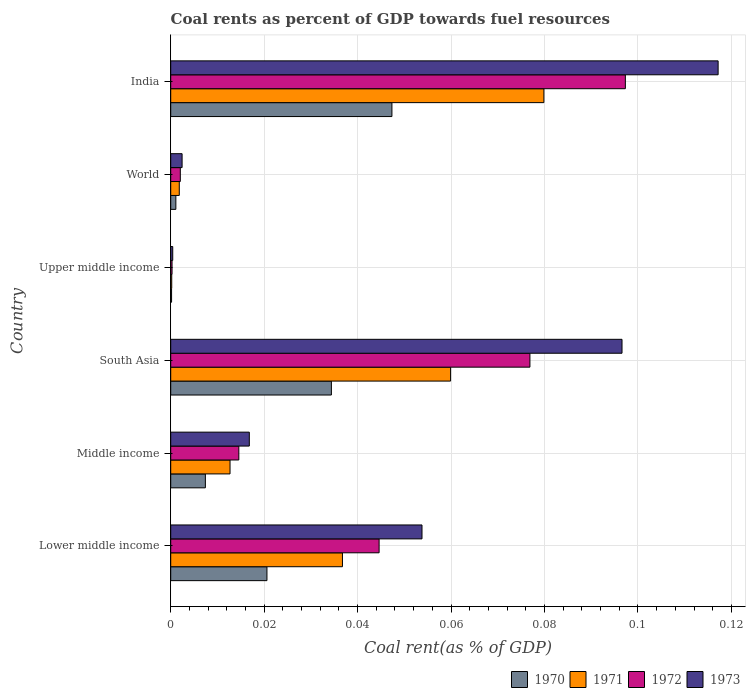How many groups of bars are there?
Offer a very short reply. 6. Are the number of bars per tick equal to the number of legend labels?
Keep it short and to the point. Yes. How many bars are there on the 3rd tick from the bottom?
Keep it short and to the point. 4. What is the label of the 4th group of bars from the top?
Your response must be concise. South Asia. In how many cases, is the number of bars for a given country not equal to the number of legend labels?
Your answer should be compact. 0. What is the coal rent in 1971 in World?
Your response must be concise. 0. Across all countries, what is the maximum coal rent in 1971?
Make the answer very short. 0.08. Across all countries, what is the minimum coal rent in 1972?
Keep it short and to the point. 0. In which country was the coal rent in 1970 minimum?
Give a very brief answer. Upper middle income. What is the total coal rent in 1970 in the graph?
Provide a succinct answer. 0.11. What is the difference between the coal rent in 1971 in Lower middle income and that in Upper middle income?
Your response must be concise. 0.04. What is the difference between the coal rent in 1971 in South Asia and the coal rent in 1972 in Middle income?
Give a very brief answer. 0.05. What is the average coal rent in 1972 per country?
Offer a terse response. 0.04. What is the difference between the coal rent in 1971 and coal rent in 1972 in South Asia?
Provide a short and direct response. -0.02. What is the ratio of the coal rent in 1970 in India to that in Upper middle income?
Offer a very short reply. 257.52. What is the difference between the highest and the second highest coal rent in 1972?
Make the answer very short. 0.02. What is the difference between the highest and the lowest coal rent in 1971?
Ensure brevity in your answer.  0.08. Is the sum of the coal rent in 1971 in Lower middle income and World greater than the maximum coal rent in 1972 across all countries?
Give a very brief answer. No. Is it the case that in every country, the sum of the coal rent in 1973 and coal rent in 1971 is greater than the sum of coal rent in 1970 and coal rent in 1972?
Give a very brief answer. No. Is it the case that in every country, the sum of the coal rent in 1973 and coal rent in 1972 is greater than the coal rent in 1970?
Provide a succinct answer. Yes. How many bars are there?
Your answer should be very brief. 24. How many countries are there in the graph?
Your answer should be compact. 6. What is the difference between two consecutive major ticks on the X-axis?
Provide a short and direct response. 0.02. How are the legend labels stacked?
Your answer should be very brief. Horizontal. What is the title of the graph?
Offer a terse response. Coal rents as percent of GDP towards fuel resources. What is the label or title of the X-axis?
Ensure brevity in your answer.  Coal rent(as % of GDP). What is the label or title of the Y-axis?
Give a very brief answer. Country. What is the Coal rent(as % of GDP) in 1970 in Lower middle income?
Offer a very short reply. 0.02. What is the Coal rent(as % of GDP) of 1971 in Lower middle income?
Your answer should be compact. 0.04. What is the Coal rent(as % of GDP) in 1972 in Lower middle income?
Ensure brevity in your answer.  0.04. What is the Coal rent(as % of GDP) in 1973 in Lower middle income?
Give a very brief answer. 0.05. What is the Coal rent(as % of GDP) in 1970 in Middle income?
Provide a short and direct response. 0.01. What is the Coal rent(as % of GDP) of 1971 in Middle income?
Make the answer very short. 0.01. What is the Coal rent(as % of GDP) in 1972 in Middle income?
Your answer should be compact. 0.01. What is the Coal rent(as % of GDP) in 1973 in Middle income?
Give a very brief answer. 0.02. What is the Coal rent(as % of GDP) of 1970 in South Asia?
Offer a very short reply. 0.03. What is the Coal rent(as % of GDP) of 1971 in South Asia?
Keep it short and to the point. 0.06. What is the Coal rent(as % of GDP) in 1972 in South Asia?
Ensure brevity in your answer.  0.08. What is the Coal rent(as % of GDP) in 1973 in South Asia?
Give a very brief answer. 0.1. What is the Coal rent(as % of GDP) in 1970 in Upper middle income?
Provide a succinct answer. 0. What is the Coal rent(as % of GDP) in 1971 in Upper middle income?
Keep it short and to the point. 0. What is the Coal rent(as % of GDP) of 1972 in Upper middle income?
Your response must be concise. 0. What is the Coal rent(as % of GDP) in 1973 in Upper middle income?
Your answer should be very brief. 0. What is the Coal rent(as % of GDP) in 1970 in World?
Give a very brief answer. 0. What is the Coal rent(as % of GDP) in 1971 in World?
Your answer should be very brief. 0. What is the Coal rent(as % of GDP) of 1972 in World?
Ensure brevity in your answer.  0. What is the Coal rent(as % of GDP) of 1973 in World?
Give a very brief answer. 0. What is the Coal rent(as % of GDP) in 1970 in India?
Your response must be concise. 0.05. What is the Coal rent(as % of GDP) in 1971 in India?
Offer a terse response. 0.08. What is the Coal rent(as % of GDP) in 1972 in India?
Make the answer very short. 0.1. What is the Coal rent(as % of GDP) of 1973 in India?
Provide a succinct answer. 0.12. Across all countries, what is the maximum Coal rent(as % of GDP) of 1970?
Keep it short and to the point. 0.05. Across all countries, what is the maximum Coal rent(as % of GDP) in 1971?
Make the answer very short. 0.08. Across all countries, what is the maximum Coal rent(as % of GDP) in 1972?
Keep it short and to the point. 0.1. Across all countries, what is the maximum Coal rent(as % of GDP) in 1973?
Provide a short and direct response. 0.12. Across all countries, what is the minimum Coal rent(as % of GDP) in 1970?
Your answer should be compact. 0. Across all countries, what is the minimum Coal rent(as % of GDP) in 1971?
Ensure brevity in your answer.  0. Across all countries, what is the minimum Coal rent(as % of GDP) of 1972?
Offer a terse response. 0. Across all countries, what is the minimum Coal rent(as % of GDP) of 1973?
Offer a terse response. 0. What is the total Coal rent(as % of GDP) in 1970 in the graph?
Your answer should be compact. 0.11. What is the total Coal rent(as % of GDP) in 1971 in the graph?
Provide a short and direct response. 0.19. What is the total Coal rent(as % of GDP) in 1972 in the graph?
Provide a short and direct response. 0.24. What is the total Coal rent(as % of GDP) of 1973 in the graph?
Offer a very short reply. 0.29. What is the difference between the Coal rent(as % of GDP) of 1970 in Lower middle income and that in Middle income?
Your answer should be compact. 0.01. What is the difference between the Coal rent(as % of GDP) in 1971 in Lower middle income and that in Middle income?
Your response must be concise. 0.02. What is the difference between the Coal rent(as % of GDP) of 1972 in Lower middle income and that in Middle income?
Your answer should be compact. 0.03. What is the difference between the Coal rent(as % of GDP) in 1973 in Lower middle income and that in Middle income?
Your answer should be very brief. 0.04. What is the difference between the Coal rent(as % of GDP) in 1970 in Lower middle income and that in South Asia?
Offer a very short reply. -0.01. What is the difference between the Coal rent(as % of GDP) in 1971 in Lower middle income and that in South Asia?
Your answer should be very brief. -0.02. What is the difference between the Coal rent(as % of GDP) in 1972 in Lower middle income and that in South Asia?
Your answer should be compact. -0.03. What is the difference between the Coal rent(as % of GDP) of 1973 in Lower middle income and that in South Asia?
Offer a very short reply. -0.04. What is the difference between the Coal rent(as % of GDP) of 1970 in Lower middle income and that in Upper middle income?
Your answer should be compact. 0.02. What is the difference between the Coal rent(as % of GDP) of 1971 in Lower middle income and that in Upper middle income?
Your answer should be very brief. 0.04. What is the difference between the Coal rent(as % of GDP) of 1972 in Lower middle income and that in Upper middle income?
Your response must be concise. 0.04. What is the difference between the Coal rent(as % of GDP) of 1973 in Lower middle income and that in Upper middle income?
Keep it short and to the point. 0.05. What is the difference between the Coal rent(as % of GDP) in 1970 in Lower middle income and that in World?
Your answer should be compact. 0.02. What is the difference between the Coal rent(as % of GDP) in 1971 in Lower middle income and that in World?
Provide a succinct answer. 0.03. What is the difference between the Coal rent(as % of GDP) in 1972 in Lower middle income and that in World?
Your answer should be compact. 0.04. What is the difference between the Coal rent(as % of GDP) of 1973 in Lower middle income and that in World?
Your answer should be compact. 0.05. What is the difference between the Coal rent(as % of GDP) of 1970 in Lower middle income and that in India?
Ensure brevity in your answer.  -0.03. What is the difference between the Coal rent(as % of GDP) of 1971 in Lower middle income and that in India?
Your answer should be very brief. -0.04. What is the difference between the Coal rent(as % of GDP) in 1972 in Lower middle income and that in India?
Provide a short and direct response. -0.05. What is the difference between the Coal rent(as % of GDP) in 1973 in Lower middle income and that in India?
Ensure brevity in your answer.  -0.06. What is the difference between the Coal rent(as % of GDP) in 1970 in Middle income and that in South Asia?
Your answer should be compact. -0.03. What is the difference between the Coal rent(as % of GDP) in 1971 in Middle income and that in South Asia?
Your answer should be compact. -0.05. What is the difference between the Coal rent(as % of GDP) in 1972 in Middle income and that in South Asia?
Provide a short and direct response. -0.06. What is the difference between the Coal rent(as % of GDP) of 1973 in Middle income and that in South Asia?
Make the answer very short. -0.08. What is the difference between the Coal rent(as % of GDP) in 1970 in Middle income and that in Upper middle income?
Offer a terse response. 0.01. What is the difference between the Coal rent(as % of GDP) of 1971 in Middle income and that in Upper middle income?
Keep it short and to the point. 0.01. What is the difference between the Coal rent(as % of GDP) in 1972 in Middle income and that in Upper middle income?
Keep it short and to the point. 0.01. What is the difference between the Coal rent(as % of GDP) in 1973 in Middle income and that in Upper middle income?
Make the answer very short. 0.02. What is the difference between the Coal rent(as % of GDP) of 1970 in Middle income and that in World?
Provide a short and direct response. 0.01. What is the difference between the Coal rent(as % of GDP) in 1971 in Middle income and that in World?
Provide a short and direct response. 0.01. What is the difference between the Coal rent(as % of GDP) of 1972 in Middle income and that in World?
Make the answer very short. 0.01. What is the difference between the Coal rent(as % of GDP) in 1973 in Middle income and that in World?
Provide a short and direct response. 0.01. What is the difference between the Coal rent(as % of GDP) of 1970 in Middle income and that in India?
Give a very brief answer. -0.04. What is the difference between the Coal rent(as % of GDP) in 1971 in Middle income and that in India?
Your response must be concise. -0.07. What is the difference between the Coal rent(as % of GDP) of 1972 in Middle income and that in India?
Your response must be concise. -0.08. What is the difference between the Coal rent(as % of GDP) of 1973 in Middle income and that in India?
Your answer should be very brief. -0.1. What is the difference between the Coal rent(as % of GDP) of 1970 in South Asia and that in Upper middle income?
Give a very brief answer. 0.03. What is the difference between the Coal rent(as % of GDP) of 1971 in South Asia and that in Upper middle income?
Your response must be concise. 0.06. What is the difference between the Coal rent(as % of GDP) of 1972 in South Asia and that in Upper middle income?
Ensure brevity in your answer.  0.08. What is the difference between the Coal rent(as % of GDP) of 1973 in South Asia and that in Upper middle income?
Your answer should be compact. 0.1. What is the difference between the Coal rent(as % of GDP) in 1970 in South Asia and that in World?
Ensure brevity in your answer.  0.03. What is the difference between the Coal rent(as % of GDP) of 1971 in South Asia and that in World?
Provide a short and direct response. 0.06. What is the difference between the Coal rent(as % of GDP) of 1972 in South Asia and that in World?
Make the answer very short. 0.07. What is the difference between the Coal rent(as % of GDP) in 1973 in South Asia and that in World?
Your answer should be very brief. 0.09. What is the difference between the Coal rent(as % of GDP) of 1970 in South Asia and that in India?
Offer a terse response. -0.01. What is the difference between the Coal rent(as % of GDP) of 1971 in South Asia and that in India?
Provide a short and direct response. -0.02. What is the difference between the Coal rent(as % of GDP) in 1972 in South Asia and that in India?
Give a very brief answer. -0.02. What is the difference between the Coal rent(as % of GDP) in 1973 in South Asia and that in India?
Provide a short and direct response. -0.02. What is the difference between the Coal rent(as % of GDP) in 1970 in Upper middle income and that in World?
Make the answer very short. -0. What is the difference between the Coal rent(as % of GDP) of 1971 in Upper middle income and that in World?
Keep it short and to the point. -0. What is the difference between the Coal rent(as % of GDP) in 1972 in Upper middle income and that in World?
Keep it short and to the point. -0. What is the difference between the Coal rent(as % of GDP) in 1973 in Upper middle income and that in World?
Provide a short and direct response. -0. What is the difference between the Coal rent(as % of GDP) in 1970 in Upper middle income and that in India?
Give a very brief answer. -0.05. What is the difference between the Coal rent(as % of GDP) of 1971 in Upper middle income and that in India?
Provide a succinct answer. -0.08. What is the difference between the Coal rent(as % of GDP) of 1972 in Upper middle income and that in India?
Your response must be concise. -0.1. What is the difference between the Coal rent(as % of GDP) of 1973 in Upper middle income and that in India?
Provide a short and direct response. -0.12. What is the difference between the Coal rent(as % of GDP) in 1970 in World and that in India?
Your answer should be compact. -0.05. What is the difference between the Coal rent(as % of GDP) of 1971 in World and that in India?
Provide a succinct answer. -0.08. What is the difference between the Coal rent(as % of GDP) in 1972 in World and that in India?
Your response must be concise. -0.1. What is the difference between the Coal rent(as % of GDP) in 1973 in World and that in India?
Provide a succinct answer. -0.11. What is the difference between the Coal rent(as % of GDP) in 1970 in Lower middle income and the Coal rent(as % of GDP) in 1971 in Middle income?
Offer a very short reply. 0.01. What is the difference between the Coal rent(as % of GDP) in 1970 in Lower middle income and the Coal rent(as % of GDP) in 1972 in Middle income?
Offer a terse response. 0.01. What is the difference between the Coal rent(as % of GDP) of 1970 in Lower middle income and the Coal rent(as % of GDP) of 1973 in Middle income?
Your answer should be compact. 0. What is the difference between the Coal rent(as % of GDP) of 1971 in Lower middle income and the Coal rent(as % of GDP) of 1972 in Middle income?
Provide a short and direct response. 0.02. What is the difference between the Coal rent(as % of GDP) of 1971 in Lower middle income and the Coal rent(as % of GDP) of 1973 in Middle income?
Make the answer very short. 0.02. What is the difference between the Coal rent(as % of GDP) of 1972 in Lower middle income and the Coal rent(as % of GDP) of 1973 in Middle income?
Offer a very short reply. 0.03. What is the difference between the Coal rent(as % of GDP) of 1970 in Lower middle income and the Coal rent(as % of GDP) of 1971 in South Asia?
Make the answer very short. -0.04. What is the difference between the Coal rent(as % of GDP) of 1970 in Lower middle income and the Coal rent(as % of GDP) of 1972 in South Asia?
Give a very brief answer. -0.06. What is the difference between the Coal rent(as % of GDP) of 1970 in Lower middle income and the Coal rent(as % of GDP) of 1973 in South Asia?
Give a very brief answer. -0.08. What is the difference between the Coal rent(as % of GDP) of 1971 in Lower middle income and the Coal rent(as % of GDP) of 1972 in South Asia?
Offer a very short reply. -0.04. What is the difference between the Coal rent(as % of GDP) of 1971 in Lower middle income and the Coal rent(as % of GDP) of 1973 in South Asia?
Keep it short and to the point. -0.06. What is the difference between the Coal rent(as % of GDP) in 1972 in Lower middle income and the Coal rent(as % of GDP) in 1973 in South Asia?
Ensure brevity in your answer.  -0.05. What is the difference between the Coal rent(as % of GDP) in 1970 in Lower middle income and the Coal rent(as % of GDP) in 1971 in Upper middle income?
Ensure brevity in your answer.  0.02. What is the difference between the Coal rent(as % of GDP) in 1970 in Lower middle income and the Coal rent(as % of GDP) in 1972 in Upper middle income?
Offer a terse response. 0.02. What is the difference between the Coal rent(as % of GDP) in 1970 in Lower middle income and the Coal rent(as % of GDP) in 1973 in Upper middle income?
Give a very brief answer. 0.02. What is the difference between the Coal rent(as % of GDP) in 1971 in Lower middle income and the Coal rent(as % of GDP) in 1972 in Upper middle income?
Your response must be concise. 0.04. What is the difference between the Coal rent(as % of GDP) in 1971 in Lower middle income and the Coal rent(as % of GDP) in 1973 in Upper middle income?
Ensure brevity in your answer.  0.04. What is the difference between the Coal rent(as % of GDP) of 1972 in Lower middle income and the Coal rent(as % of GDP) of 1973 in Upper middle income?
Ensure brevity in your answer.  0.04. What is the difference between the Coal rent(as % of GDP) in 1970 in Lower middle income and the Coal rent(as % of GDP) in 1971 in World?
Provide a succinct answer. 0.02. What is the difference between the Coal rent(as % of GDP) in 1970 in Lower middle income and the Coal rent(as % of GDP) in 1972 in World?
Offer a terse response. 0.02. What is the difference between the Coal rent(as % of GDP) of 1970 in Lower middle income and the Coal rent(as % of GDP) of 1973 in World?
Your answer should be compact. 0.02. What is the difference between the Coal rent(as % of GDP) of 1971 in Lower middle income and the Coal rent(as % of GDP) of 1972 in World?
Ensure brevity in your answer.  0.03. What is the difference between the Coal rent(as % of GDP) in 1971 in Lower middle income and the Coal rent(as % of GDP) in 1973 in World?
Offer a terse response. 0.03. What is the difference between the Coal rent(as % of GDP) in 1972 in Lower middle income and the Coal rent(as % of GDP) in 1973 in World?
Give a very brief answer. 0.04. What is the difference between the Coal rent(as % of GDP) of 1970 in Lower middle income and the Coal rent(as % of GDP) of 1971 in India?
Provide a short and direct response. -0.06. What is the difference between the Coal rent(as % of GDP) of 1970 in Lower middle income and the Coal rent(as % of GDP) of 1972 in India?
Your response must be concise. -0.08. What is the difference between the Coal rent(as % of GDP) of 1970 in Lower middle income and the Coal rent(as % of GDP) of 1973 in India?
Your answer should be very brief. -0.1. What is the difference between the Coal rent(as % of GDP) of 1971 in Lower middle income and the Coal rent(as % of GDP) of 1972 in India?
Your answer should be very brief. -0.06. What is the difference between the Coal rent(as % of GDP) in 1971 in Lower middle income and the Coal rent(as % of GDP) in 1973 in India?
Keep it short and to the point. -0.08. What is the difference between the Coal rent(as % of GDP) in 1972 in Lower middle income and the Coal rent(as % of GDP) in 1973 in India?
Your answer should be very brief. -0.07. What is the difference between the Coal rent(as % of GDP) of 1970 in Middle income and the Coal rent(as % of GDP) of 1971 in South Asia?
Ensure brevity in your answer.  -0.05. What is the difference between the Coal rent(as % of GDP) of 1970 in Middle income and the Coal rent(as % of GDP) of 1972 in South Asia?
Ensure brevity in your answer.  -0.07. What is the difference between the Coal rent(as % of GDP) of 1970 in Middle income and the Coal rent(as % of GDP) of 1973 in South Asia?
Your response must be concise. -0.09. What is the difference between the Coal rent(as % of GDP) in 1971 in Middle income and the Coal rent(as % of GDP) in 1972 in South Asia?
Offer a terse response. -0.06. What is the difference between the Coal rent(as % of GDP) in 1971 in Middle income and the Coal rent(as % of GDP) in 1973 in South Asia?
Your answer should be compact. -0.08. What is the difference between the Coal rent(as % of GDP) in 1972 in Middle income and the Coal rent(as % of GDP) in 1973 in South Asia?
Ensure brevity in your answer.  -0.08. What is the difference between the Coal rent(as % of GDP) of 1970 in Middle income and the Coal rent(as % of GDP) of 1971 in Upper middle income?
Make the answer very short. 0.01. What is the difference between the Coal rent(as % of GDP) of 1970 in Middle income and the Coal rent(as % of GDP) of 1972 in Upper middle income?
Provide a succinct answer. 0.01. What is the difference between the Coal rent(as % of GDP) in 1970 in Middle income and the Coal rent(as % of GDP) in 1973 in Upper middle income?
Provide a short and direct response. 0.01. What is the difference between the Coal rent(as % of GDP) of 1971 in Middle income and the Coal rent(as % of GDP) of 1972 in Upper middle income?
Your answer should be very brief. 0.01. What is the difference between the Coal rent(as % of GDP) in 1971 in Middle income and the Coal rent(as % of GDP) in 1973 in Upper middle income?
Your answer should be very brief. 0.01. What is the difference between the Coal rent(as % of GDP) of 1972 in Middle income and the Coal rent(as % of GDP) of 1973 in Upper middle income?
Offer a terse response. 0.01. What is the difference between the Coal rent(as % of GDP) in 1970 in Middle income and the Coal rent(as % of GDP) in 1971 in World?
Your response must be concise. 0.01. What is the difference between the Coal rent(as % of GDP) of 1970 in Middle income and the Coal rent(as % of GDP) of 1972 in World?
Your answer should be very brief. 0.01. What is the difference between the Coal rent(as % of GDP) in 1970 in Middle income and the Coal rent(as % of GDP) in 1973 in World?
Your response must be concise. 0.01. What is the difference between the Coal rent(as % of GDP) of 1971 in Middle income and the Coal rent(as % of GDP) of 1972 in World?
Offer a terse response. 0.01. What is the difference between the Coal rent(as % of GDP) in 1971 in Middle income and the Coal rent(as % of GDP) in 1973 in World?
Give a very brief answer. 0.01. What is the difference between the Coal rent(as % of GDP) in 1972 in Middle income and the Coal rent(as % of GDP) in 1973 in World?
Offer a terse response. 0.01. What is the difference between the Coal rent(as % of GDP) in 1970 in Middle income and the Coal rent(as % of GDP) in 1971 in India?
Offer a terse response. -0.07. What is the difference between the Coal rent(as % of GDP) of 1970 in Middle income and the Coal rent(as % of GDP) of 1972 in India?
Keep it short and to the point. -0.09. What is the difference between the Coal rent(as % of GDP) in 1970 in Middle income and the Coal rent(as % of GDP) in 1973 in India?
Provide a short and direct response. -0.11. What is the difference between the Coal rent(as % of GDP) in 1971 in Middle income and the Coal rent(as % of GDP) in 1972 in India?
Give a very brief answer. -0.08. What is the difference between the Coal rent(as % of GDP) of 1971 in Middle income and the Coal rent(as % of GDP) of 1973 in India?
Give a very brief answer. -0.1. What is the difference between the Coal rent(as % of GDP) in 1972 in Middle income and the Coal rent(as % of GDP) in 1973 in India?
Give a very brief answer. -0.1. What is the difference between the Coal rent(as % of GDP) in 1970 in South Asia and the Coal rent(as % of GDP) in 1971 in Upper middle income?
Offer a very short reply. 0.03. What is the difference between the Coal rent(as % of GDP) in 1970 in South Asia and the Coal rent(as % of GDP) in 1972 in Upper middle income?
Make the answer very short. 0.03. What is the difference between the Coal rent(as % of GDP) of 1970 in South Asia and the Coal rent(as % of GDP) of 1973 in Upper middle income?
Provide a succinct answer. 0.03. What is the difference between the Coal rent(as % of GDP) of 1971 in South Asia and the Coal rent(as % of GDP) of 1972 in Upper middle income?
Ensure brevity in your answer.  0.06. What is the difference between the Coal rent(as % of GDP) of 1971 in South Asia and the Coal rent(as % of GDP) of 1973 in Upper middle income?
Offer a very short reply. 0.06. What is the difference between the Coal rent(as % of GDP) in 1972 in South Asia and the Coal rent(as % of GDP) in 1973 in Upper middle income?
Keep it short and to the point. 0.08. What is the difference between the Coal rent(as % of GDP) in 1970 in South Asia and the Coal rent(as % of GDP) in 1971 in World?
Provide a short and direct response. 0.03. What is the difference between the Coal rent(as % of GDP) of 1970 in South Asia and the Coal rent(as % of GDP) of 1972 in World?
Your response must be concise. 0.03. What is the difference between the Coal rent(as % of GDP) in 1970 in South Asia and the Coal rent(as % of GDP) in 1973 in World?
Provide a succinct answer. 0.03. What is the difference between the Coal rent(as % of GDP) in 1971 in South Asia and the Coal rent(as % of GDP) in 1972 in World?
Provide a succinct answer. 0.06. What is the difference between the Coal rent(as % of GDP) of 1971 in South Asia and the Coal rent(as % of GDP) of 1973 in World?
Offer a terse response. 0.06. What is the difference between the Coal rent(as % of GDP) of 1972 in South Asia and the Coal rent(as % of GDP) of 1973 in World?
Provide a short and direct response. 0.07. What is the difference between the Coal rent(as % of GDP) in 1970 in South Asia and the Coal rent(as % of GDP) in 1971 in India?
Keep it short and to the point. -0.05. What is the difference between the Coal rent(as % of GDP) of 1970 in South Asia and the Coal rent(as % of GDP) of 1972 in India?
Make the answer very short. -0.06. What is the difference between the Coal rent(as % of GDP) of 1970 in South Asia and the Coal rent(as % of GDP) of 1973 in India?
Your response must be concise. -0.08. What is the difference between the Coal rent(as % of GDP) in 1971 in South Asia and the Coal rent(as % of GDP) in 1972 in India?
Ensure brevity in your answer.  -0.04. What is the difference between the Coal rent(as % of GDP) of 1971 in South Asia and the Coal rent(as % of GDP) of 1973 in India?
Your answer should be very brief. -0.06. What is the difference between the Coal rent(as % of GDP) of 1972 in South Asia and the Coal rent(as % of GDP) of 1973 in India?
Offer a terse response. -0.04. What is the difference between the Coal rent(as % of GDP) of 1970 in Upper middle income and the Coal rent(as % of GDP) of 1971 in World?
Your response must be concise. -0. What is the difference between the Coal rent(as % of GDP) in 1970 in Upper middle income and the Coal rent(as % of GDP) in 1972 in World?
Keep it short and to the point. -0. What is the difference between the Coal rent(as % of GDP) of 1970 in Upper middle income and the Coal rent(as % of GDP) of 1973 in World?
Your answer should be compact. -0. What is the difference between the Coal rent(as % of GDP) in 1971 in Upper middle income and the Coal rent(as % of GDP) in 1972 in World?
Your answer should be very brief. -0. What is the difference between the Coal rent(as % of GDP) of 1971 in Upper middle income and the Coal rent(as % of GDP) of 1973 in World?
Offer a very short reply. -0. What is the difference between the Coal rent(as % of GDP) in 1972 in Upper middle income and the Coal rent(as % of GDP) in 1973 in World?
Offer a terse response. -0. What is the difference between the Coal rent(as % of GDP) of 1970 in Upper middle income and the Coal rent(as % of GDP) of 1971 in India?
Offer a terse response. -0.08. What is the difference between the Coal rent(as % of GDP) of 1970 in Upper middle income and the Coal rent(as % of GDP) of 1972 in India?
Your response must be concise. -0.1. What is the difference between the Coal rent(as % of GDP) of 1970 in Upper middle income and the Coal rent(as % of GDP) of 1973 in India?
Your answer should be compact. -0.12. What is the difference between the Coal rent(as % of GDP) of 1971 in Upper middle income and the Coal rent(as % of GDP) of 1972 in India?
Keep it short and to the point. -0.1. What is the difference between the Coal rent(as % of GDP) of 1971 in Upper middle income and the Coal rent(as % of GDP) of 1973 in India?
Provide a short and direct response. -0.12. What is the difference between the Coal rent(as % of GDP) of 1972 in Upper middle income and the Coal rent(as % of GDP) of 1973 in India?
Give a very brief answer. -0.12. What is the difference between the Coal rent(as % of GDP) in 1970 in World and the Coal rent(as % of GDP) in 1971 in India?
Make the answer very short. -0.08. What is the difference between the Coal rent(as % of GDP) of 1970 in World and the Coal rent(as % of GDP) of 1972 in India?
Make the answer very short. -0.1. What is the difference between the Coal rent(as % of GDP) in 1970 in World and the Coal rent(as % of GDP) in 1973 in India?
Your answer should be compact. -0.12. What is the difference between the Coal rent(as % of GDP) of 1971 in World and the Coal rent(as % of GDP) of 1972 in India?
Ensure brevity in your answer.  -0.1. What is the difference between the Coal rent(as % of GDP) of 1971 in World and the Coal rent(as % of GDP) of 1973 in India?
Give a very brief answer. -0.12. What is the difference between the Coal rent(as % of GDP) in 1972 in World and the Coal rent(as % of GDP) in 1973 in India?
Your answer should be very brief. -0.12. What is the average Coal rent(as % of GDP) in 1970 per country?
Give a very brief answer. 0.02. What is the average Coal rent(as % of GDP) in 1971 per country?
Offer a very short reply. 0.03. What is the average Coal rent(as % of GDP) in 1972 per country?
Make the answer very short. 0.04. What is the average Coal rent(as % of GDP) in 1973 per country?
Provide a short and direct response. 0.05. What is the difference between the Coal rent(as % of GDP) in 1970 and Coal rent(as % of GDP) in 1971 in Lower middle income?
Give a very brief answer. -0.02. What is the difference between the Coal rent(as % of GDP) of 1970 and Coal rent(as % of GDP) of 1972 in Lower middle income?
Give a very brief answer. -0.02. What is the difference between the Coal rent(as % of GDP) of 1970 and Coal rent(as % of GDP) of 1973 in Lower middle income?
Your answer should be very brief. -0.03. What is the difference between the Coal rent(as % of GDP) of 1971 and Coal rent(as % of GDP) of 1972 in Lower middle income?
Your answer should be compact. -0.01. What is the difference between the Coal rent(as % of GDP) in 1971 and Coal rent(as % of GDP) in 1973 in Lower middle income?
Ensure brevity in your answer.  -0.02. What is the difference between the Coal rent(as % of GDP) in 1972 and Coal rent(as % of GDP) in 1973 in Lower middle income?
Offer a terse response. -0.01. What is the difference between the Coal rent(as % of GDP) of 1970 and Coal rent(as % of GDP) of 1971 in Middle income?
Keep it short and to the point. -0.01. What is the difference between the Coal rent(as % of GDP) in 1970 and Coal rent(as % of GDP) in 1972 in Middle income?
Make the answer very short. -0.01. What is the difference between the Coal rent(as % of GDP) in 1970 and Coal rent(as % of GDP) in 1973 in Middle income?
Give a very brief answer. -0.01. What is the difference between the Coal rent(as % of GDP) of 1971 and Coal rent(as % of GDP) of 1972 in Middle income?
Offer a very short reply. -0. What is the difference between the Coal rent(as % of GDP) of 1971 and Coal rent(as % of GDP) of 1973 in Middle income?
Keep it short and to the point. -0. What is the difference between the Coal rent(as % of GDP) in 1972 and Coal rent(as % of GDP) in 1973 in Middle income?
Your answer should be compact. -0. What is the difference between the Coal rent(as % of GDP) of 1970 and Coal rent(as % of GDP) of 1971 in South Asia?
Ensure brevity in your answer.  -0.03. What is the difference between the Coal rent(as % of GDP) of 1970 and Coal rent(as % of GDP) of 1972 in South Asia?
Offer a very short reply. -0.04. What is the difference between the Coal rent(as % of GDP) of 1970 and Coal rent(as % of GDP) of 1973 in South Asia?
Keep it short and to the point. -0.06. What is the difference between the Coal rent(as % of GDP) of 1971 and Coal rent(as % of GDP) of 1972 in South Asia?
Offer a very short reply. -0.02. What is the difference between the Coal rent(as % of GDP) of 1971 and Coal rent(as % of GDP) of 1973 in South Asia?
Your answer should be compact. -0.04. What is the difference between the Coal rent(as % of GDP) in 1972 and Coal rent(as % of GDP) in 1973 in South Asia?
Your response must be concise. -0.02. What is the difference between the Coal rent(as % of GDP) of 1970 and Coal rent(as % of GDP) of 1972 in Upper middle income?
Provide a succinct answer. -0. What is the difference between the Coal rent(as % of GDP) of 1970 and Coal rent(as % of GDP) of 1973 in Upper middle income?
Your response must be concise. -0. What is the difference between the Coal rent(as % of GDP) of 1971 and Coal rent(as % of GDP) of 1972 in Upper middle income?
Your answer should be compact. -0. What is the difference between the Coal rent(as % of GDP) in 1971 and Coal rent(as % of GDP) in 1973 in Upper middle income?
Your answer should be compact. -0. What is the difference between the Coal rent(as % of GDP) of 1972 and Coal rent(as % of GDP) of 1973 in Upper middle income?
Provide a short and direct response. -0. What is the difference between the Coal rent(as % of GDP) of 1970 and Coal rent(as % of GDP) of 1971 in World?
Your answer should be compact. -0. What is the difference between the Coal rent(as % of GDP) in 1970 and Coal rent(as % of GDP) in 1972 in World?
Your answer should be compact. -0. What is the difference between the Coal rent(as % of GDP) of 1970 and Coal rent(as % of GDP) of 1973 in World?
Offer a very short reply. -0. What is the difference between the Coal rent(as % of GDP) in 1971 and Coal rent(as % of GDP) in 1972 in World?
Make the answer very short. -0. What is the difference between the Coal rent(as % of GDP) of 1971 and Coal rent(as % of GDP) of 1973 in World?
Your response must be concise. -0. What is the difference between the Coal rent(as % of GDP) in 1972 and Coal rent(as % of GDP) in 1973 in World?
Ensure brevity in your answer.  -0. What is the difference between the Coal rent(as % of GDP) of 1970 and Coal rent(as % of GDP) of 1971 in India?
Offer a very short reply. -0.03. What is the difference between the Coal rent(as % of GDP) in 1970 and Coal rent(as % of GDP) in 1973 in India?
Make the answer very short. -0.07. What is the difference between the Coal rent(as % of GDP) in 1971 and Coal rent(as % of GDP) in 1972 in India?
Make the answer very short. -0.02. What is the difference between the Coal rent(as % of GDP) in 1971 and Coal rent(as % of GDP) in 1973 in India?
Make the answer very short. -0.04. What is the difference between the Coal rent(as % of GDP) in 1972 and Coal rent(as % of GDP) in 1973 in India?
Provide a succinct answer. -0.02. What is the ratio of the Coal rent(as % of GDP) of 1970 in Lower middle income to that in Middle income?
Provide a succinct answer. 2.78. What is the ratio of the Coal rent(as % of GDP) in 1971 in Lower middle income to that in Middle income?
Your answer should be very brief. 2.9. What is the ratio of the Coal rent(as % of GDP) of 1972 in Lower middle income to that in Middle income?
Offer a very short reply. 3.06. What is the ratio of the Coal rent(as % of GDP) in 1973 in Lower middle income to that in Middle income?
Your answer should be very brief. 3.2. What is the ratio of the Coal rent(as % of GDP) of 1970 in Lower middle income to that in South Asia?
Your response must be concise. 0.6. What is the ratio of the Coal rent(as % of GDP) in 1971 in Lower middle income to that in South Asia?
Provide a short and direct response. 0.61. What is the ratio of the Coal rent(as % of GDP) in 1972 in Lower middle income to that in South Asia?
Offer a terse response. 0.58. What is the ratio of the Coal rent(as % of GDP) in 1973 in Lower middle income to that in South Asia?
Your answer should be compact. 0.56. What is the ratio of the Coal rent(as % of GDP) in 1970 in Lower middle income to that in Upper middle income?
Your answer should be very brief. 112.03. What is the ratio of the Coal rent(as % of GDP) in 1971 in Lower middle income to that in Upper middle income?
Your response must be concise. 167.98. What is the ratio of the Coal rent(as % of GDP) of 1972 in Lower middle income to that in Upper middle income?
Make the answer very short. 156.82. What is the ratio of the Coal rent(as % of GDP) of 1973 in Lower middle income to that in Upper middle income?
Provide a succinct answer. 124.82. What is the ratio of the Coal rent(as % of GDP) of 1970 in Lower middle income to that in World?
Make the answer very short. 18.71. What is the ratio of the Coal rent(as % of GDP) in 1971 in Lower middle income to that in World?
Provide a succinct answer. 20.06. What is the ratio of the Coal rent(as % of GDP) of 1972 in Lower middle income to that in World?
Provide a short and direct response. 21.7. What is the ratio of the Coal rent(as % of GDP) of 1973 in Lower middle income to that in World?
Provide a succinct answer. 22.07. What is the ratio of the Coal rent(as % of GDP) of 1970 in Lower middle income to that in India?
Provide a short and direct response. 0.44. What is the ratio of the Coal rent(as % of GDP) of 1971 in Lower middle income to that in India?
Your response must be concise. 0.46. What is the ratio of the Coal rent(as % of GDP) in 1972 in Lower middle income to that in India?
Provide a succinct answer. 0.46. What is the ratio of the Coal rent(as % of GDP) in 1973 in Lower middle income to that in India?
Keep it short and to the point. 0.46. What is the ratio of the Coal rent(as % of GDP) of 1970 in Middle income to that in South Asia?
Offer a very short reply. 0.22. What is the ratio of the Coal rent(as % of GDP) of 1971 in Middle income to that in South Asia?
Keep it short and to the point. 0.21. What is the ratio of the Coal rent(as % of GDP) of 1972 in Middle income to that in South Asia?
Your answer should be compact. 0.19. What is the ratio of the Coal rent(as % of GDP) in 1973 in Middle income to that in South Asia?
Give a very brief answer. 0.17. What is the ratio of the Coal rent(as % of GDP) of 1970 in Middle income to that in Upper middle income?
Keep it short and to the point. 40.36. What is the ratio of the Coal rent(as % of GDP) in 1971 in Middle income to that in Upper middle income?
Give a very brief answer. 58.01. What is the ratio of the Coal rent(as % of GDP) of 1972 in Middle income to that in Upper middle income?
Provide a short and direct response. 51.25. What is the ratio of the Coal rent(as % of GDP) of 1973 in Middle income to that in Upper middle income?
Your response must be concise. 39.04. What is the ratio of the Coal rent(as % of GDP) in 1970 in Middle income to that in World?
Provide a short and direct response. 6.74. What is the ratio of the Coal rent(as % of GDP) of 1971 in Middle income to that in World?
Give a very brief answer. 6.93. What is the ratio of the Coal rent(as % of GDP) of 1972 in Middle income to that in World?
Ensure brevity in your answer.  7.09. What is the ratio of the Coal rent(as % of GDP) of 1973 in Middle income to that in World?
Give a very brief answer. 6.91. What is the ratio of the Coal rent(as % of GDP) of 1970 in Middle income to that in India?
Your answer should be very brief. 0.16. What is the ratio of the Coal rent(as % of GDP) of 1971 in Middle income to that in India?
Provide a succinct answer. 0.16. What is the ratio of the Coal rent(as % of GDP) in 1972 in Middle income to that in India?
Ensure brevity in your answer.  0.15. What is the ratio of the Coal rent(as % of GDP) in 1973 in Middle income to that in India?
Your answer should be very brief. 0.14. What is the ratio of the Coal rent(as % of GDP) in 1970 in South Asia to that in Upper middle income?
Ensure brevity in your answer.  187.05. What is the ratio of the Coal rent(as % of GDP) of 1971 in South Asia to that in Upper middle income?
Keep it short and to the point. 273.74. What is the ratio of the Coal rent(as % of GDP) in 1972 in South Asia to that in Upper middle income?
Your answer should be compact. 270.32. What is the ratio of the Coal rent(as % of GDP) in 1973 in South Asia to that in Upper middle income?
Provide a short and direct response. 224.18. What is the ratio of the Coal rent(as % of GDP) in 1970 in South Asia to that in World?
Offer a very short reply. 31.24. What is the ratio of the Coal rent(as % of GDP) of 1971 in South Asia to that in World?
Provide a succinct answer. 32.69. What is the ratio of the Coal rent(as % of GDP) in 1972 in South Asia to that in World?
Ensure brevity in your answer.  37.41. What is the ratio of the Coal rent(as % of GDP) in 1973 in South Asia to that in World?
Offer a terse response. 39.65. What is the ratio of the Coal rent(as % of GDP) in 1970 in South Asia to that in India?
Your response must be concise. 0.73. What is the ratio of the Coal rent(as % of GDP) of 1971 in South Asia to that in India?
Give a very brief answer. 0.75. What is the ratio of the Coal rent(as % of GDP) of 1972 in South Asia to that in India?
Your response must be concise. 0.79. What is the ratio of the Coal rent(as % of GDP) in 1973 in South Asia to that in India?
Ensure brevity in your answer.  0.82. What is the ratio of the Coal rent(as % of GDP) in 1970 in Upper middle income to that in World?
Provide a succinct answer. 0.17. What is the ratio of the Coal rent(as % of GDP) of 1971 in Upper middle income to that in World?
Ensure brevity in your answer.  0.12. What is the ratio of the Coal rent(as % of GDP) in 1972 in Upper middle income to that in World?
Provide a short and direct response. 0.14. What is the ratio of the Coal rent(as % of GDP) in 1973 in Upper middle income to that in World?
Offer a very short reply. 0.18. What is the ratio of the Coal rent(as % of GDP) of 1970 in Upper middle income to that in India?
Your answer should be compact. 0. What is the ratio of the Coal rent(as % of GDP) in 1971 in Upper middle income to that in India?
Make the answer very short. 0. What is the ratio of the Coal rent(as % of GDP) of 1972 in Upper middle income to that in India?
Make the answer very short. 0. What is the ratio of the Coal rent(as % of GDP) in 1973 in Upper middle income to that in India?
Offer a very short reply. 0. What is the ratio of the Coal rent(as % of GDP) of 1970 in World to that in India?
Provide a succinct answer. 0.02. What is the ratio of the Coal rent(as % of GDP) of 1971 in World to that in India?
Your answer should be compact. 0.02. What is the ratio of the Coal rent(as % of GDP) in 1972 in World to that in India?
Make the answer very short. 0.02. What is the ratio of the Coal rent(as % of GDP) in 1973 in World to that in India?
Give a very brief answer. 0.02. What is the difference between the highest and the second highest Coal rent(as % of GDP) in 1970?
Offer a very short reply. 0.01. What is the difference between the highest and the second highest Coal rent(as % of GDP) of 1972?
Keep it short and to the point. 0.02. What is the difference between the highest and the second highest Coal rent(as % of GDP) of 1973?
Your response must be concise. 0.02. What is the difference between the highest and the lowest Coal rent(as % of GDP) in 1970?
Your answer should be very brief. 0.05. What is the difference between the highest and the lowest Coal rent(as % of GDP) of 1971?
Offer a terse response. 0.08. What is the difference between the highest and the lowest Coal rent(as % of GDP) in 1972?
Keep it short and to the point. 0.1. What is the difference between the highest and the lowest Coal rent(as % of GDP) of 1973?
Your answer should be compact. 0.12. 